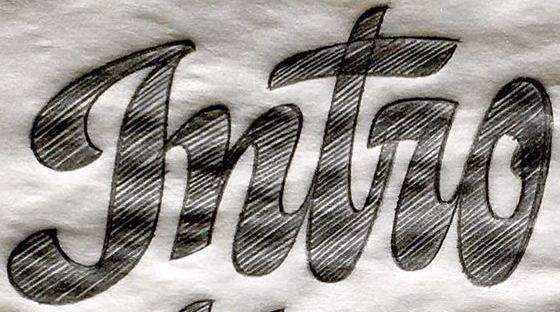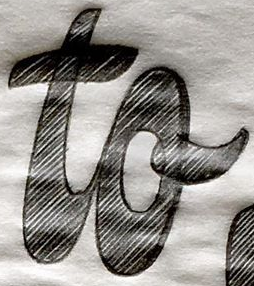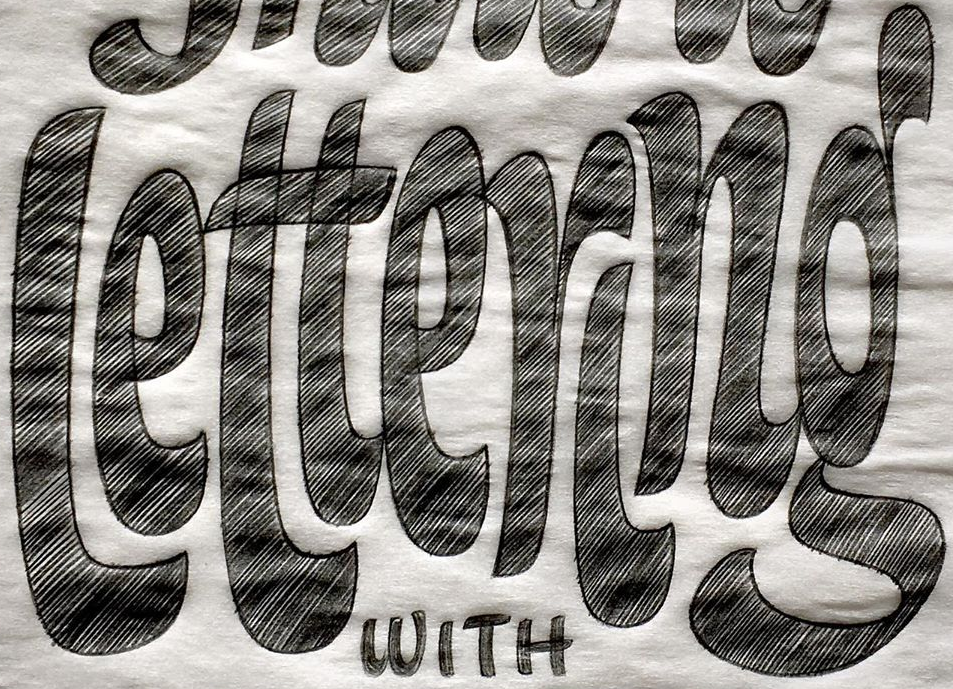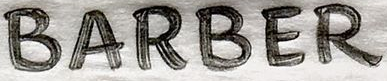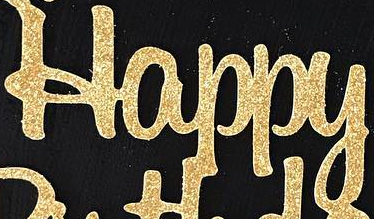Transcribe the words shown in these images in order, separated by a semicolon. gntro; to; lettering; BARBER; Happy 